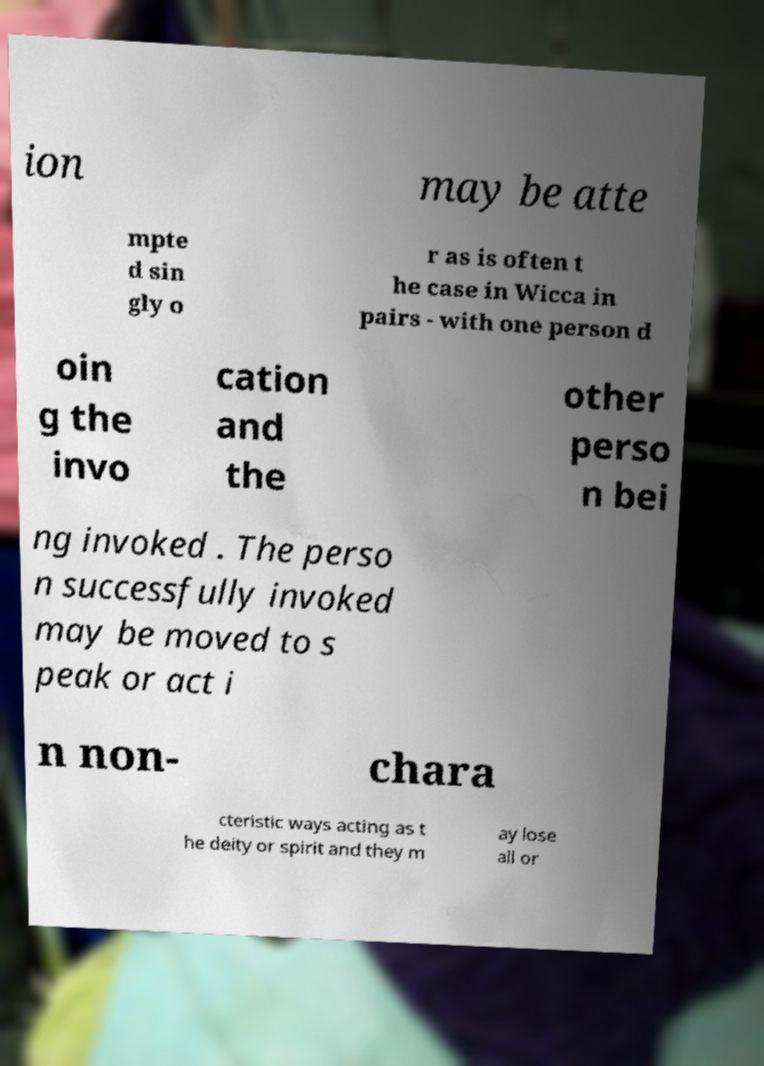I need the written content from this picture converted into text. Can you do that? ion may be atte mpte d sin gly o r as is often t he case in Wicca in pairs - with one person d oin g the invo cation and the other perso n bei ng invoked . The perso n successfully invoked may be moved to s peak or act i n non- chara cteristic ways acting as t he deity or spirit and they m ay lose all or 